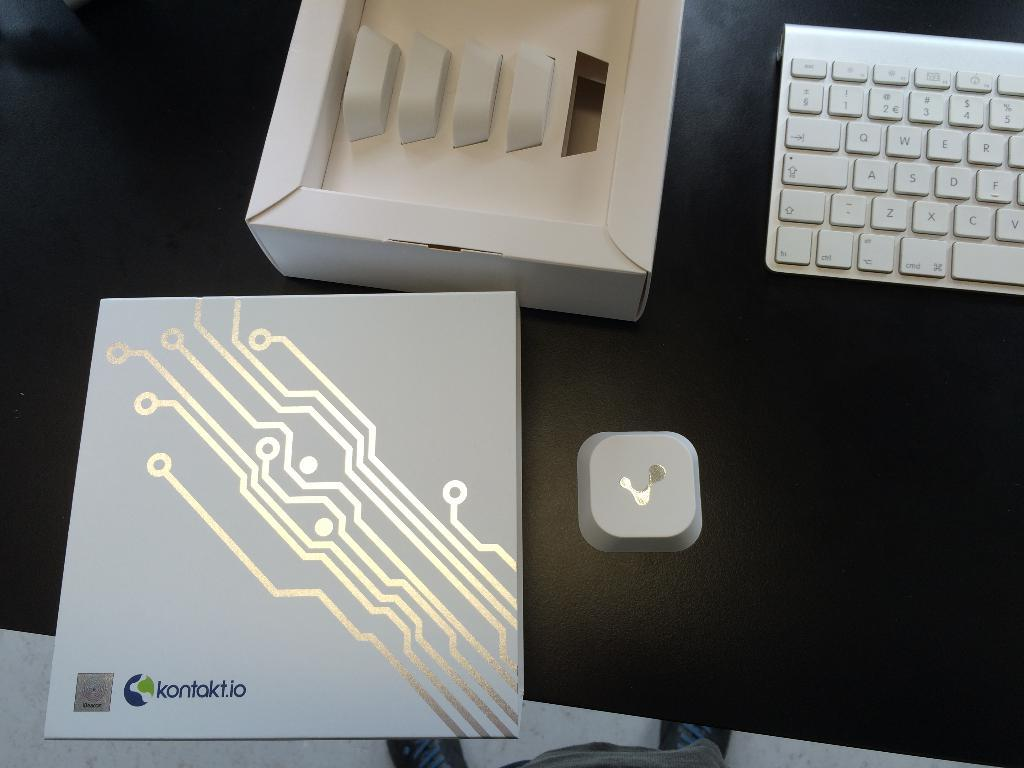What is the color of the table in the image? The table in the image is black. What objects are placed on the table? Two boxes and a keyboard are placed on the table. What is the color of the object on the table? The object on the table is white. What can be seen at the bottom of the image? The floor is visible at the bottom of the image. Who is the owner of the ant in the image? There is no ant present in the image, so it is not possible to determine the owner. 